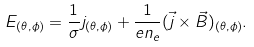<formula> <loc_0><loc_0><loc_500><loc_500>E _ { ( \theta , \phi ) } = \frac { 1 } { \sigma } j _ { ( \theta , \phi ) } + \frac { 1 } { e n _ { e } } ( \vec { j } \times \vec { B } ) _ { ( \theta , \phi ) } .</formula> 